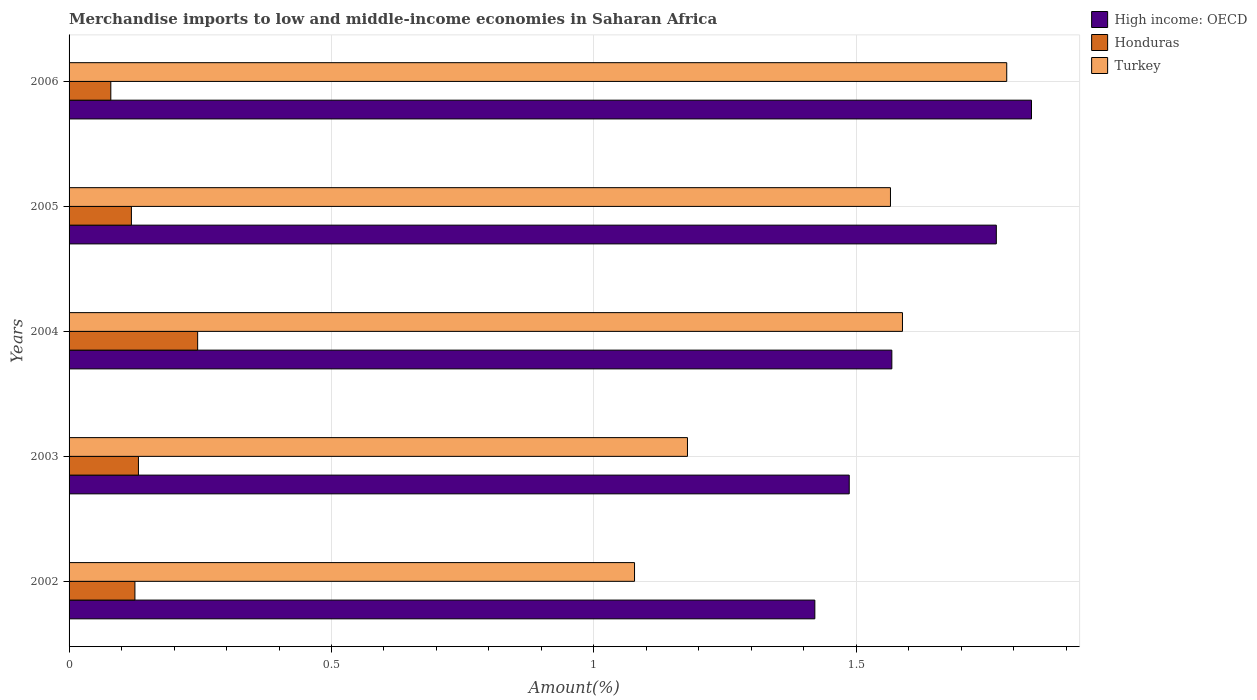How many different coloured bars are there?
Give a very brief answer. 3. How many groups of bars are there?
Your answer should be very brief. 5. Are the number of bars per tick equal to the number of legend labels?
Give a very brief answer. Yes. Are the number of bars on each tick of the Y-axis equal?
Your answer should be compact. Yes. What is the percentage of amount earned from merchandise imports in Turkey in 2002?
Ensure brevity in your answer.  1.08. Across all years, what is the maximum percentage of amount earned from merchandise imports in Honduras?
Your response must be concise. 0.25. Across all years, what is the minimum percentage of amount earned from merchandise imports in High income: OECD?
Your answer should be compact. 1.42. In which year was the percentage of amount earned from merchandise imports in Turkey maximum?
Your answer should be compact. 2006. What is the total percentage of amount earned from merchandise imports in Honduras in the graph?
Keep it short and to the point. 0.7. What is the difference between the percentage of amount earned from merchandise imports in High income: OECD in 2004 and that in 2005?
Give a very brief answer. -0.2. What is the difference between the percentage of amount earned from merchandise imports in Turkey in 2004 and the percentage of amount earned from merchandise imports in Honduras in 2006?
Provide a succinct answer. 1.51. What is the average percentage of amount earned from merchandise imports in High income: OECD per year?
Provide a short and direct response. 1.62. In the year 2003, what is the difference between the percentage of amount earned from merchandise imports in High income: OECD and percentage of amount earned from merchandise imports in Turkey?
Keep it short and to the point. 0.31. What is the ratio of the percentage of amount earned from merchandise imports in High income: OECD in 2002 to that in 2003?
Provide a short and direct response. 0.96. What is the difference between the highest and the second highest percentage of amount earned from merchandise imports in High income: OECD?
Offer a terse response. 0.07. What is the difference between the highest and the lowest percentage of amount earned from merchandise imports in Turkey?
Offer a very short reply. 0.71. Is the sum of the percentage of amount earned from merchandise imports in Turkey in 2005 and 2006 greater than the maximum percentage of amount earned from merchandise imports in Honduras across all years?
Provide a short and direct response. Yes. What does the 3rd bar from the top in 2002 represents?
Provide a succinct answer. High income: OECD. Is it the case that in every year, the sum of the percentage of amount earned from merchandise imports in Turkey and percentage of amount earned from merchandise imports in Honduras is greater than the percentage of amount earned from merchandise imports in High income: OECD?
Make the answer very short. No. Are all the bars in the graph horizontal?
Your response must be concise. Yes. How are the legend labels stacked?
Provide a short and direct response. Vertical. What is the title of the graph?
Ensure brevity in your answer.  Merchandise imports to low and middle-income economies in Saharan Africa. What is the label or title of the X-axis?
Make the answer very short. Amount(%). What is the label or title of the Y-axis?
Your answer should be very brief. Years. What is the Amount(%) in High income: OECD in 2002?
Keep it short and to the point. 1.42. What is the Amount(%) of Honduras in 2002?
Provide a short and direct response. 0.13. What is the Amount(%) of Turkey in 2002?
Your response must be concise. 1.08. What is the Amount(%) in High income: OECD in 2003?
Offer a terse response. 1.49. What is the Amount(%) in Honduras in 2003?
Offer a terse response. 0.13. What is the Amount(%) in Turkey in 2003?
Provide a succinct answer. 1.18. What is the Amount(%) of High income: OECD in 2004?
Keep it short and to the point. 1.57. What is the Amount(%) in Honduras in 2004?
Your answer should be very brief. 0.25. What is the Amount(%) of Turkey in 2004?
Provide a succinct answer. 1.59. What is the Amount(%) of High income: OECD in 2005?
Offer a terse response. 1.77. What is the Amount(%) in Honduras in 2005?
Give a very brief answer. 0.12. What is the Amount(%) of Turkey in 2005?
Your response must be concise. 1.57. What is the Amount(%) in High income: OECD in 2006?
Keep it short and to the point. 1.83. What is the Amount(%) of Honduras in 2006?
Provide a succinct answer. 0.08. What is the Amount(%) of Turkey in 2006?
Offer a terse response. 1.79. Across all years, what is the maximum Amount(%) in High income: OECD?
Offer a very short reply. 1.83. Across all years, what is the maximum Amount(%) in Honduras?
Make the answer very short. 0.25. Across all years, what is the maximum Amount(%) of Turkey?
Make the answer very short. 1.79. Across all years, what is the minimum Amount(%) of High income: OECD?
Provide a short and direct response. 1.42. Across all years, what is the minimum Amount(%) of Honduras?
Ensure brevity in your answer.  0.08. Across all years, what is the minimum Amount(%) in Turkey?
Keep it short and to the point. 1.08. What is the total Amount(%) in High income: OECD in the graph?
Make the answer very short. 8.08. What is the total Amount(%) of Honduras in the graph?
Offer a very short reply. 0.7. What is the total Amount(%) in Turkey in the graph?
Your response must be concise. 7.2. What is the difference between the Amount(%) of High income: OECD in 2002 and that in 2003?
Provide a short and direct response. -0.07. What is the difference between the Amount(%) in Honduras in 2002 and that in 2003?
Ensure brevity in your answer.  -0.01. What is the difference between the Amount(%) in Turkey in 2002 and that in 2003?
Make the answer very short. -0.1. What is the difference between the Amount(%) in High income: OECD in 2002 and that in 2004?
Offer a terse response. -0.15. What is the difference between the Amount(%) of Honduras in 2002 and that in 2004?
Your response must be concise. -0.12. What is the difference between the Amount(%) in Turkey in 2002 and that in 2004?
Your answer should be very brief. -0.51. What is the difference between the Amount(%) in High income: OECD in 2002 and that in 2005?
Ensure brevity in your answer.  -0.35. What is the difference between the Amount(%) of Honduras in 2002 and that in 2005?
Your response must be concise. 0.01. What is the difference between the Amount(%) of Turkey in 2002 and that in 2005?
Give a very brief answer. -0.49. What is the difference between the Amount(%) of High income: OECD in 2002 and that in 2006?
Ensure brevity in your answer.  -0.41. What is the difference between the Amount(%) of Honduras in 2002 and that in 2006?
Offer a terse response. 0.05. What is the difference between the Amount(%) in Turkey in 2002 and that in 2006?
Ensure brevity in your answer.  -0.71. What is the difference between the Amount(%) in High income: OECD in 2003 and that in 2004?
Your response must be concise. -0.08. What is the difference between the Amount(%) in Honduras in 2003 and that in 2004?
Keep it short and to the point. -0.11. What is the difference between the Amount(%) in Turkey in 2003 and that in 2004?
Ensure brevity in your answer.  -0.41. What is the difference between the Amount(%) in High income: OECD in 2003 and that in 2005?
Make the answer very short. -0.28. What is the difference between the Amount(%) of Honduras in 2003 and that in 2005?
Your response must be concise. 0.01. What is the difference between the Amount(%) of Turkey in 2003 and that in 2005?
Give a very brief answer. -0.39. What is the difference between the Amount(%) of High income: OECD in 2003 and that in 2006?
Your answer should be very brief. -0.35. What is the difference between the Amount(%) of Honduras in 2003 and that in 2006?
Offer a terse response. 0.05. What is the difference between the Amount(%) in Turkey in 2003 and that in 2006?
Provide a short and direct response. -0.61. What is the difference between the Amount(%) of High income: OECD in 2004 and that in 2005?
Provide a succinct answer. -0.2. What is the difference between the Amount(%) of Honduras in 2004 and that in 2005?
Make the answer very short. 0.13. What is the difference between the Amount(%) in Turkey in 2004 and that in 2005?
Your answer should be compact. 0.02. What is the difference between the Amount(%) in High income: OECD in 2004 and that in 2006?
Provide a succinct answer. -0.27. What is the difference between the Amount(%) in Honduras in 2004 and that in 2006?
Keep it short and to the point. 0.17. What is the difference between the Amount(%) in Turkey in 2004 and that in 2006?
Give a very brief answer. -0.2. What is the difference between the Amount(%) of High income: OECD in 2005 and that in 2006?
Your answer should be very brief. -0.07. What is the difference between the Amount(%) in Honduras in 2005 and that in 2006?
Give a very brief answer. 0.04. What is the difference between the Amount(%) of Turkey in 2005 and that in 2006?
Provide a succinct answer. -0.22. What is the difference between the Amount(%) in High income: OECD in 2002 and the Amount(%) in Honduras in 2003?
Offer a terse response. 1.29. What is the difference between the Amount(%) of High income: OECD in 2002 and the Amount(%) of Turkey in 2003?
Ensure brevity in your answer.  0.24. What is the difference between the Amount(%) in Honduras in 2002 and the Amount(%) in Turkey in 2003?
Offer a terse response. -1.05. What is the difference between the Amount(%) of High income: OECD in 2002 and the Amount(%) of Honduras in 2004?
Your response must be concise. 1.18. What is the difference between the Amount(%) in High income: OECD in 2002 and the Amount(%) in Turkey in 2004?
Give a very brief answer. -0.17. What is the difference between the Amount(%) of Honduras in 2002 and the Amount(%) of Turkey in 2004?
Give a very brief answer. -1.46. What is the difference between the Amount(%) of High income: OECD in 2002 and the Amount(%) of Honduras in 2005?
Your response must be concise. 1.3. What is the difference between the Amount(%) of High income: OECD in 2002 and the Amount(%) of Turkey in 2005?
Provide a succinct answer. -0.14. What is the difference between the Amount(%) in Honduras in 2002 and the Amount(%) in Turkey in 2005?
Give a very brief answer. -1.44. What is the difference between the Amount(%) of High income: OECD in 2002 and the Amount(%) of Honduras in 2006?
Your response must be concise. 1.34. What is the difference between the Amount(%) of High income: OECD in 2002 and the Amount(%) of Turkey in 2006?
Provide a short and direct response. -0.37. What is the difference between the Amount(%) in Honduras in 2002 and the Amount(%) in Turkey in 2006?
Offer a very short reply. -1.66. What is the difference between the Amount(%) in High income: OECD in 2003 and the Amount(%) in Honduras in 2004?
Make the answer very short. 1.24. What is the difference between the Amount(%) in High income: OECD in 2003 and the Amount(%) in Turkey in 2004?
Offer a terse response. -0.1. What is the difference between the Amount(%) of Honduras in 2003 and the Amount(%) of Turkey in 2004?
Your response must be concise. -1.46. What is the difference between the Amount(%) of High income: OECD in 2003 and the Amount(%) of Honduras in 2005?
Ensure brevity in your answer.  1.37. What is the difference between the Amount(%) of High income: OECD in 2003 and the Amount(%) of Turkey in 2005?
Your answer should be very brief. -0.08. What is the difference between the Amount(%) of Honduras in 2003 and the Amount(%) of Turkey in 2005?
Your answer should be very brief. -1.43. What is the difference between the Amount(%) in High income: OECD in 2003 and the Amount(%) in Honduras in 2006?
Provide a succinct answer. 1.41. What is the difference between the Amount(%) of High income: OECD in 2003 and the Amount(%) of Turkey in 2006?
Give a very brief answer. -0.3. What is the difference between the Amount(%) of Honduras in 2003 and the Amount(%) of Turkey in 2006?
Make the answer very short. -1.65. What is the difference between the Amount(%) of High income: OECD in 2004 and the Amount(%) of Honduras in 2005?
Keep it short and to the point. 1.45. What is the difference between the Amount(%) of High income: OECD in 2004 and the Amount(%) of Turkey in 2005?
Make the answer very short. 0. What is the difference between the Amount(%) of Honduras in 2004 and the Amount(%) of Turkey in 2005?
Your response must be concise. -1.32. What is the difference between the Amount(%) of High income: OECD in 2004 and the Amount(%) of Honduras in 2006?
Give a very brief answer. 1.49. What is the difference between the Amount(%) of High income: OECD in 2004 and the Amount(%) of Turkey in 2006?
Ensure brevity in your answer.  -0.22. What is the difference between the Amount(%) of Honduras in 2004 and the Amount(%) of Turkey in 2006?
Your answer should be very brief. -1.54. What is the difference between the Amount(%) of High income: OECD in 2005 and the Amount(%) of Honduras in 2006?
Your answer should be very brief. 1.69. What is the difference between the Amount(%) of High income: OECD in 2005 and the Amount(%) of Turkey in 2006?
Make the answer very short. -0.02. What is the difference between the Amount(%) in Honduras in 2005 and the Amount(%) in Turkey in 2006?
Keep it short and to the point. -1.67. What is the average Amount(%) of High income: OECD per year?
Your answer should be very brief. 1.62. What is the average Amount(%) in Honduras per year?
Give a very brief answer. 0.14. What is the average Amount(%) in Turkey per year?
Offer a very short reply. 1.44. In the year 2002, what is the difference between the Amount(%) in High income: OECD and Amount(%) in Honduras?
Make the answer very short. 1.3. In the year 2002, what is the difference between the Amount(%) of High income: OECD and Amount(%) of Turkey?
Ensure brevity in your answer.  0.34. In the year 2002, what is the difference between the Amount(%) in Honduras and Amount(%) in Turkey?
Your answer should be very brief. -0.95. In the year 2003, what is the difference between the Amount(%) of High income: OECD and Amount(%) of Honduras?
Your answer should be very brief. 1.35. In the year 2003, what is the difference between the Amount(%) in High income: OECD and Amount(%) in Turkey?
Offer a terse response. 0.31. In the year 2003, what is the difference between the Amount(%) in Honduras and Amount(%) in Turkey?
Your response must be concise. -1.05. In the year 2004, what is the difference between the Amount(%) in High income: OECD and Amount(%) in Honduras?
Keep it short and to the point. 1.32. In the year 2004, what is the difference between the Amount(%) in High income: OECD and Amount(%) in Turkey?
Your response must be concise. -0.02. In the year 2004, what is the difference between the Amount(%) in Honduras and Amount(%) in Turkey?
Your response must be concise. -1.34. In the year 2005, what is the difference between the Amount(%) in High income: OECD and Amount(%) in Honduras?
Give a very brief answer. 1.65. In the year 2005, what is the difference between the Amount(%) in High income: OECD and Amount(%) in Turkey?
Give a very brief answer. 0.2. In the year 2005, what is the difference between the Amount(%) in Honduras and Amount(%) in Turkey?
Your response must be concise. -1.45. In the year 2006, what is the difference between the Amount(%) of High income: OECD and Amount(%) of Honduras?
Your answer should be very brief. 1.75. In the year 2006, what is the difference between the Amount(%) in High income: OECD and Amount(%) in Turkey?
Your answer should be compact. 0.05. In the year 2006, what is the difference between the Amount(%) in Honduras and Amount(%) in Turkey?
Provide a short and direct response. -1.71. What is the ratio of the Amount(%) in High income: OECD in 2002 to that in 2003?
Your answer should be compact. 0.96. What is the ratio of the Amount(%) of Honduras in 2002 to that in 2003?
Give a very brief answer. 0.95. What is the ratio of the Amount(%) in Turkey in 2002 to that in 2003?
Provide a short and direct response. 0.91. What is the ratio of the Amount(%) in High income: OECD in 2002 to that in 2004?
Your answer should be compact. 0.91. What is the ratio of the Amount(%) of Honduras in 2002 to that in 2004?
Offer a terse response. 0.51. What is the ratio of the Amount(%) in Turkey in 2002 to that in 2004?
Keep it short and to the point. 0.68. What is the ratio of the Amount(%) in High income: OECD in 2002 to that in 2005?
Your answer should be very brief. 0.8. What is the ratio of the Amount(%) of Honduras in 2002 to that in 2005?
Your answer should be very brief. 1.06. What is the ratio of the Amount(%) of Turkey in 2002 to that in 2005?
Offer a very short reply. 0.69. What is the ratio of the Amount(%) in High income: OECD in 2002 to that in 2006?
Keep it short and to the point. 0.77. What is the ratio of the Amount(%) in Honduras in 2002 to that in 2006?
Ensure brevity in your answer.  1.58. What is the ratio of the Amount(%) in Turkey in 2002 to that in 2006?
Your answer should be very brief. 0.6. What is the ratio of the Amount(%) of High income: OECD in 2003 to that in 2004?
Keep it short and to the point. 0.95. What is the ratio of the Amount(%) of Honduras in 2003 to that in 2004?
Your answer should be very brief. 0.54. What is the ratio of the Amount(%) of Turkey in 2003 to that in 2004?
Keep it short and to the point. 0.74. What is the ratio of the Amount(%) in High income: OECD in 2003 to that in 2005?
Your answer should be compact. 0.84. What is the ratio of the Amount(%) in Honduras in 2003 to that in 2005?
Make the answer very short. 1.11. What is the ratio of the Amount(%) in Turkey in 2003 to that in 2005?
Your answer should be very brief. 0.75. What is the ratio of the Amount(%) of High income: OECD in 2003 to that in 2006?
Your answer should be very brief. 0.81. What is the ratio of the Amount(%) in Honduras in 2003 to that in 2006?
Provide a short and direct response. 1.66. What is the ratio of the Amount(%) in Turkey in 2003 to that in 2006?
Provide a short and direct response. 0.66. What is the ratio of the Amount(%) of High income: OECD in 2004 to that in 2005?
Your answer should be very brief. 0.89. What is the ratio of the Amount(%) of Honduras in 2004 to that in 2005?
Provide a succinct answer. 2.06. What is the ratio of the Amount(%) of Turkey in 2004 to that in 2005?
Offer a terse response. 1.01. What is the ratio of the Amount(%) of High income: OECD in 2004 to that in 2006?
Offer a terse response. 0.85. What is the ratio of the Amount(%) of Honduras in 2004 to that in 2006?
Your response must be concise. 3.08. What is the ratio of the Amount(%) of Turkey in 2004 to that in 2006?
Offer a terse response. 0.89. What is the ratio of the Amount(%) in High income: OECD in 2005 to that in 2006?
Ensure brevity in your answer.  0.96. What is the ratio of the Amount(%) in Honduras in 2005 to that in 2006?
Offer a terse response. 1.49. What is the ratio of the Amount(%) in Turkey in 2005 to that in 2006?
Keep it short and to the point. 0.88. What is the difference between the highest and the second highest Amount(%) in High income: OECD?
Offer a terse response. 0.07. What is the difference between the highest and the second highest Amount(%) in Honduras?
Provide a short and direct response. 0.11. What is the difference between the highest and the second highest Amount(%) in Turkey?
Your answer should be compact. 0.2. What is the difference between the highest and the lowest Amount(%) of High income: OECD?
Your response must be concise. 0.41. What is the difference between the highest and the lowest Amount(%) of Honduras?
Give a very brief answer. 0.17. What is the difference between the highest and the lowest Amount(%) in Turkey?
Ensure brevity in your answer.  0.71. 